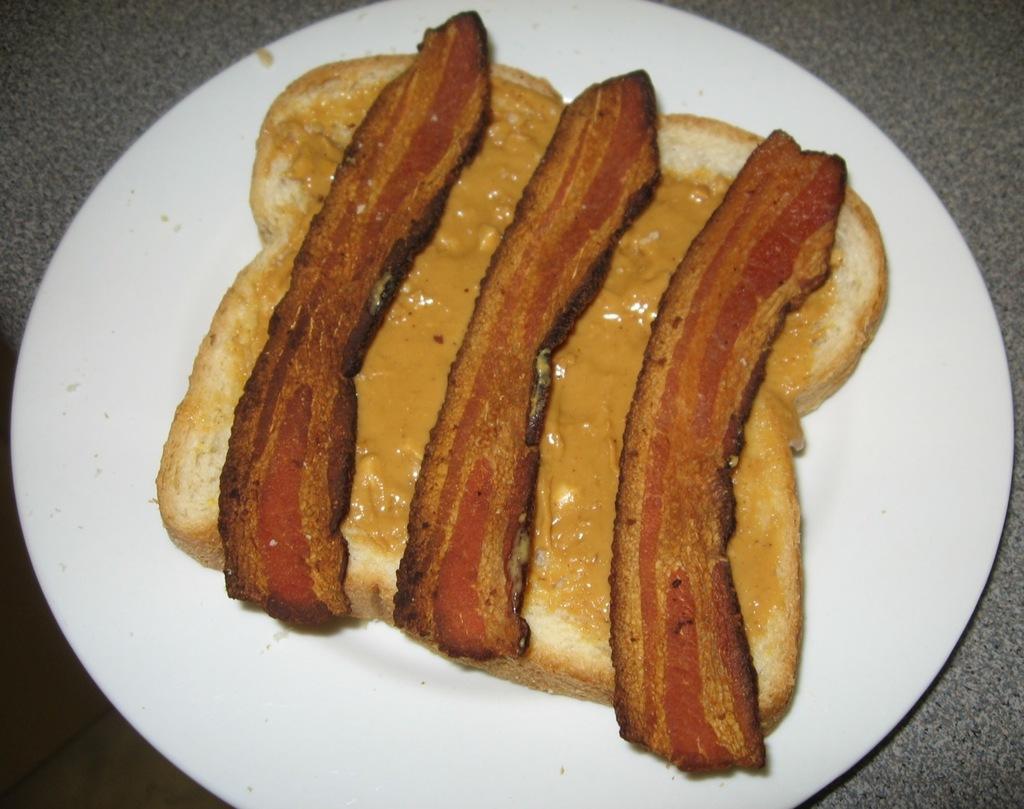Describe this image in one or two sentences. In this image we can see a white color plate with some food. 